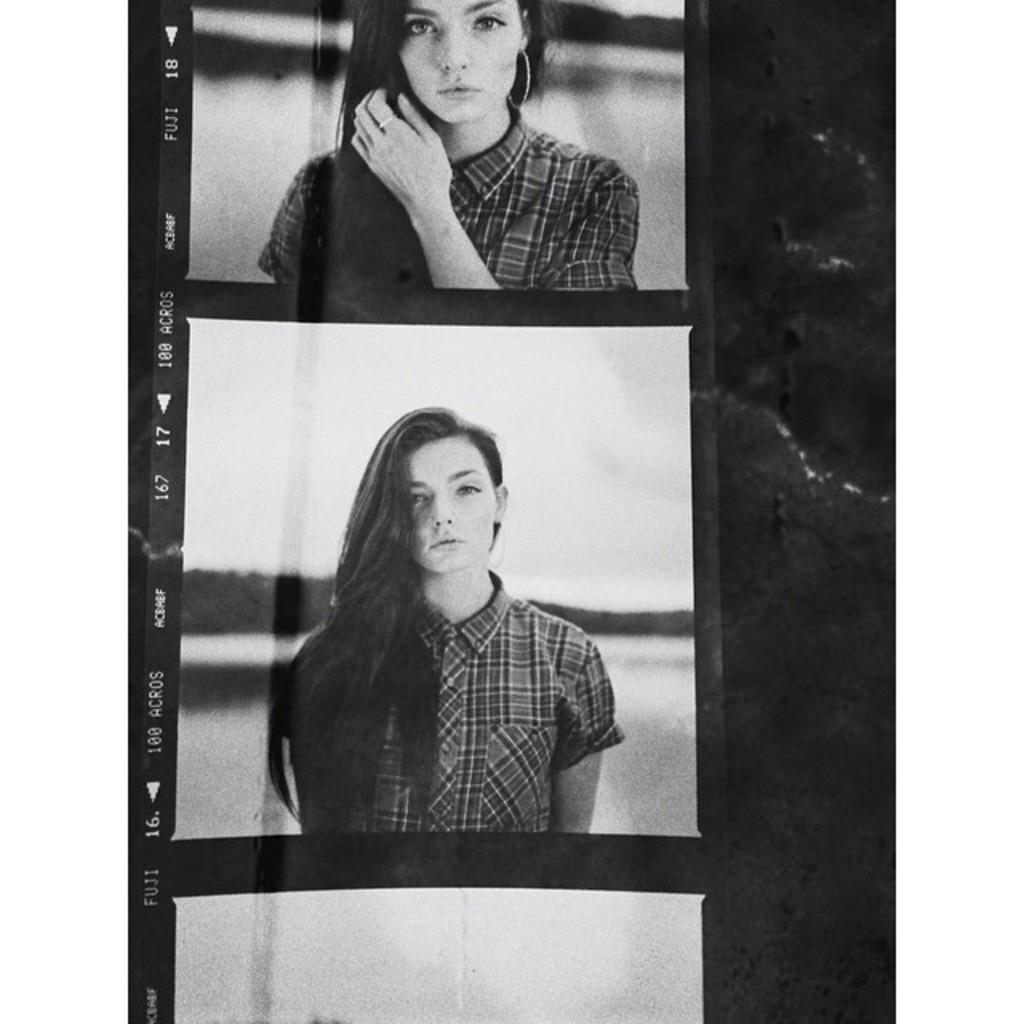What is depicted in the image? There are photographs of a person in the image. What additional features can be seen on the photographs? There is text on the photographs, and the borders of the photographs are white in color. What type of hat is the person wearing in the image? There is no person present in the image, only photographs of a person. Therefore, it is not possible to determine what type of hat the person might be wearing. 